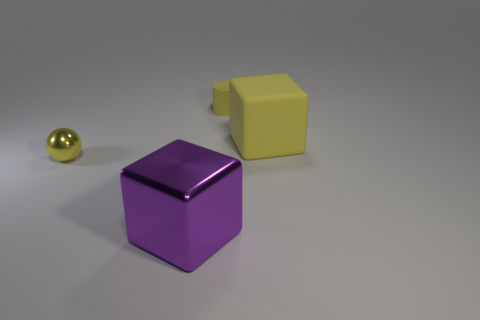Add 2 gray cubes. How many objects exist? 6 Subtract all spheres. How many objects are left? 3 Subtract all yellow balls. Subtract all yellow blocks. How many objects are left? 2 Add 2 tiny yellow cylinders. How many tiny yellow cylinders are left? 3 Add 4 tiny yellow cylinders. How many tiny yellow cylinders exist? 5 Subtract 0 brown spheres. How many objects are left? 4 